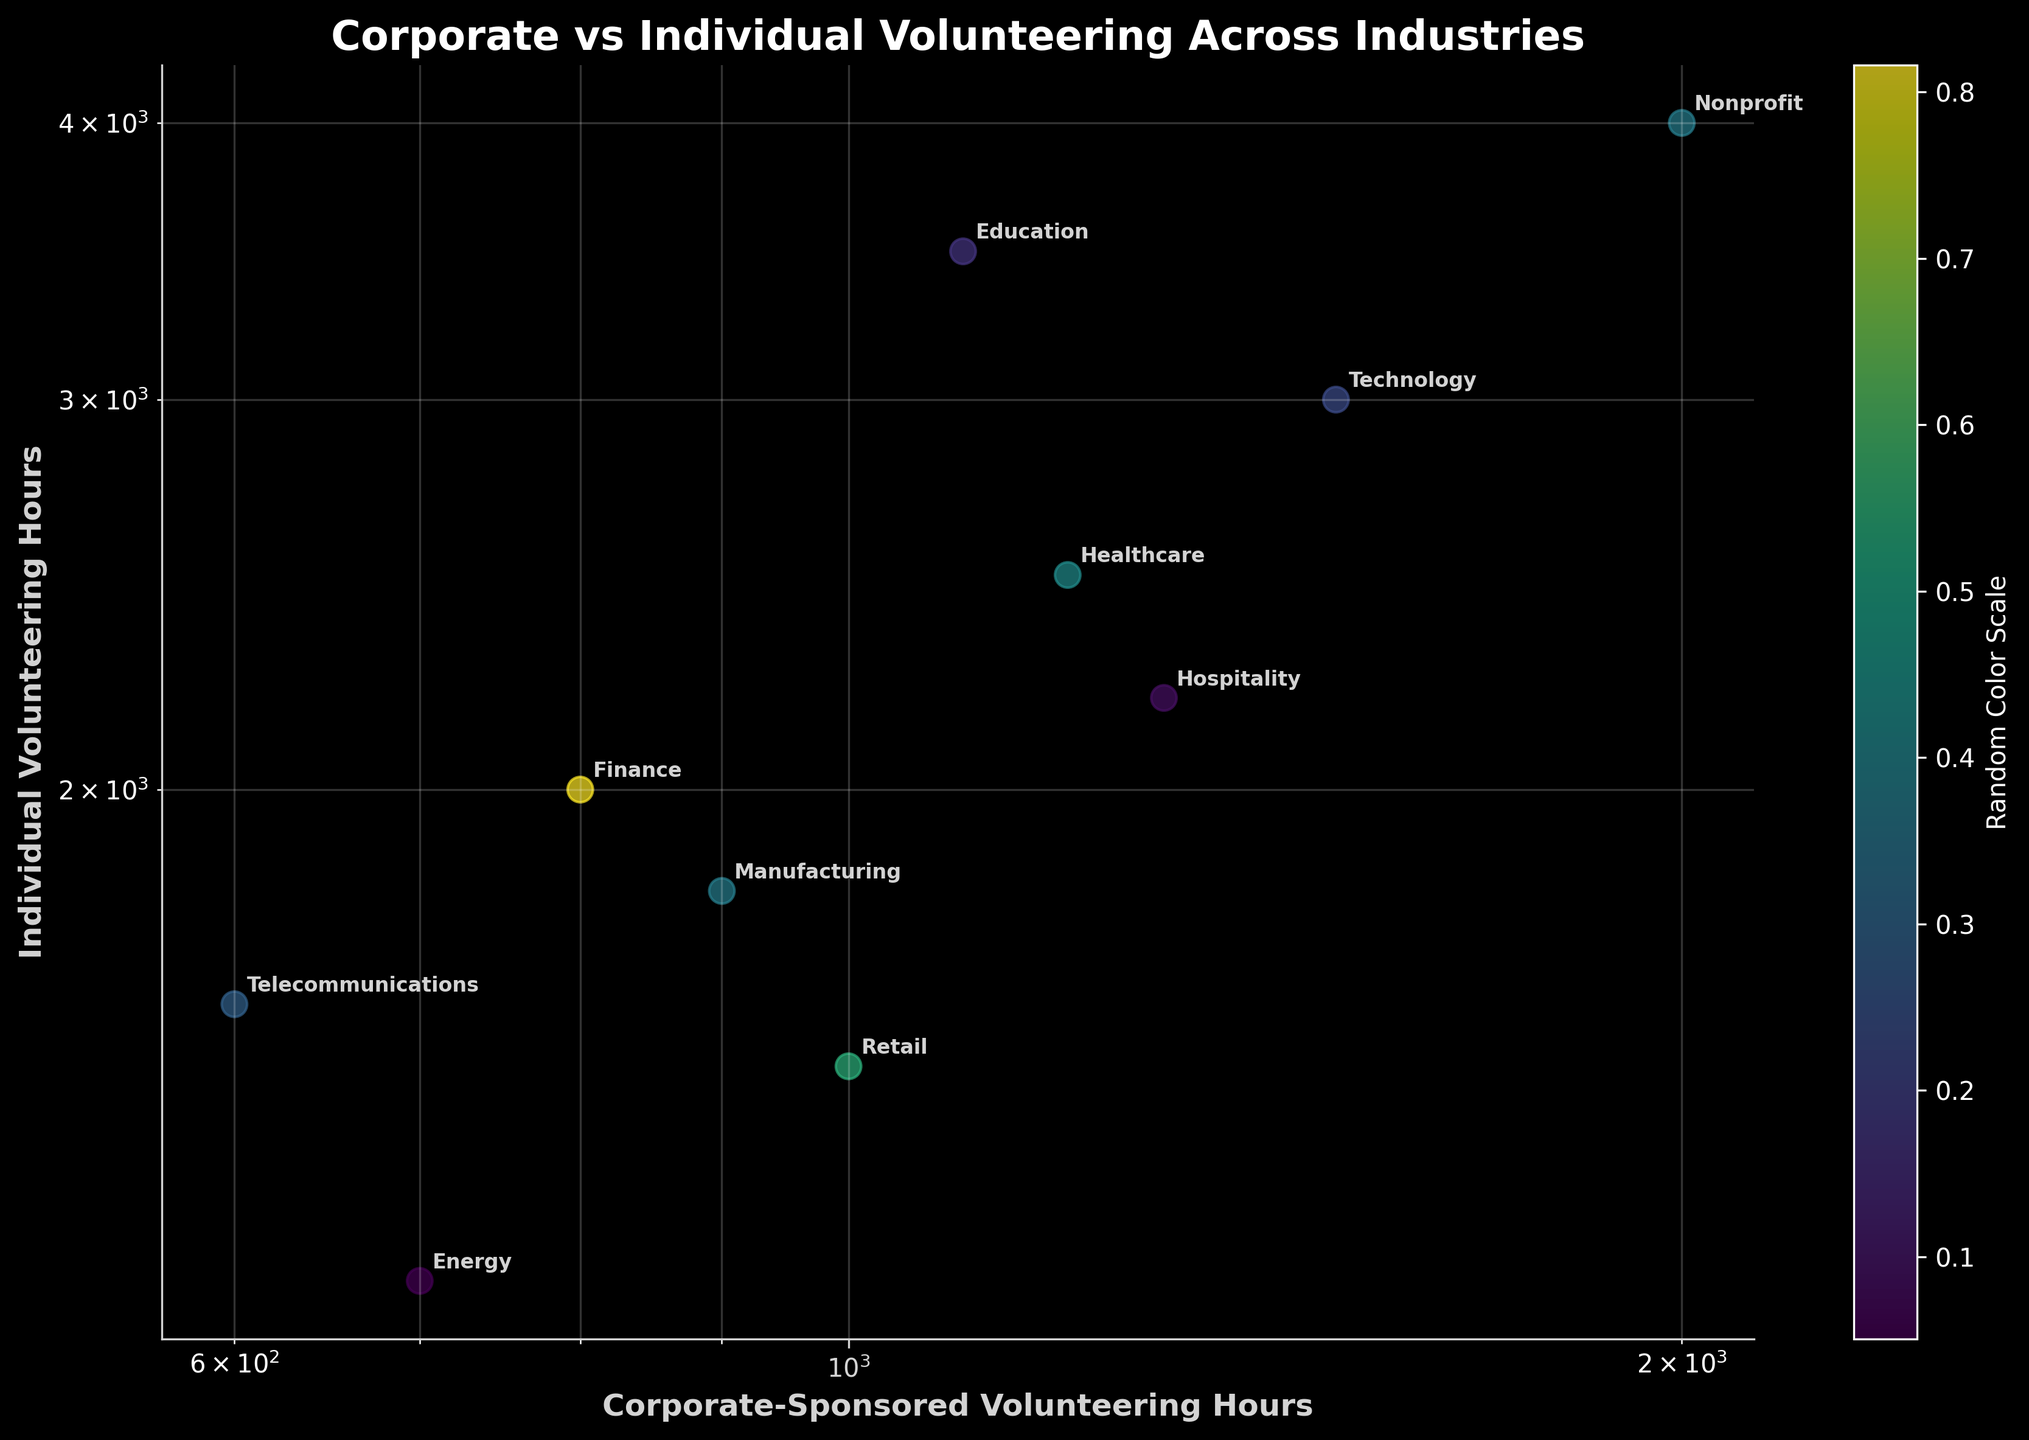What is the title of the scatter plot? The title is located at the top of the scatter plot. In this case, the title reads "Corporate vs Individual Volunteering Across Industries".
Answer: Corporate vs Individual Volunteering Across Industries How many industries are represented in the scatter plot? Each data point corresponds to an industry, and the industries are labeled next to each point. By counting the labels, we can determine there are 10 industries shown.
Answer: 10 Which industry has the highest number of individual volunteering hours? On the scatter plot, the y-axis represents individual volunteering hours. The data point with the highest position on the y-axis is labeled "Nonprofit".
Answer: Nonprofit What are the corporate-sponsored and individual volunteering hours for the Technology industry? Locate the labeled point "Technology" on the scatter plot. The x-coordinate represents corporate-sponsored hours (1500) and the y-coordinate represents individual volunteering hours (3000).
Answer: 1500 corporate-sponsored, 3000 individual Which two industries have the closest number of corporate-sponsored volunteering hours? Review the x-axis for industries with similar positions. The closest are "Finance" and "Manufacturing", with Finance at 800 hours and Manufacturing at 900 hours.
Answer: Finance and Manufacturing What is the general trend between corporate-sponsored and individual volunteering hours based on the scatter plot visualization? The scatter plot shows a positive correlation; as corporate-sponsored volunteering hours increase, individual volunteering hours also tend to increase. This trend is observed from the upward trajectory of the points in the plot.
Answer: Positive correlation How does the volunteering effort in the Hospitality industry compare to the Energy industry in terms of both corporate-sponsored and individual volunteering hours? Locate the Hospitality and Energy points. Hospitality has 1300 corporate-sponsored and 2200 individual hours, while Energy has 700 corporate-sponsored and 1200 individual hours. Hospitality has higher values on both axes compared to Energy.
Answer: Hospitality has higher values in both aspects Which industry has the least amount of corporate-sponsored volunteering hours? Locate the data point closest to the origin on the x-axis. The point labeled "Telecommunications" shows the least, with 600 hours.
Answer: Telecommunications Is there an industry that has an equal or higher number of individual volunteering hours compared to corporate-sponsored ones? Identify data points where the y-coordinate (individual hours) is equal to or higher than the x-coordinate (corporate hours). For example, Nonprofit has higher individual (4000) than corporate-sponsored (2000) hours.
Answer: Nonprofit and others What industries form a cluster in the low end of corporate-sponsored volunteering hours (less than 1000)? Look at sectors on the left side of the plot with x-values less than 1000. The industries in this cluster are Finance, Retail, Manufacturing, Energy, and Telecommunications.
Answer: Finance, Retail, Manufacturing, Energy, and Telecommunications 